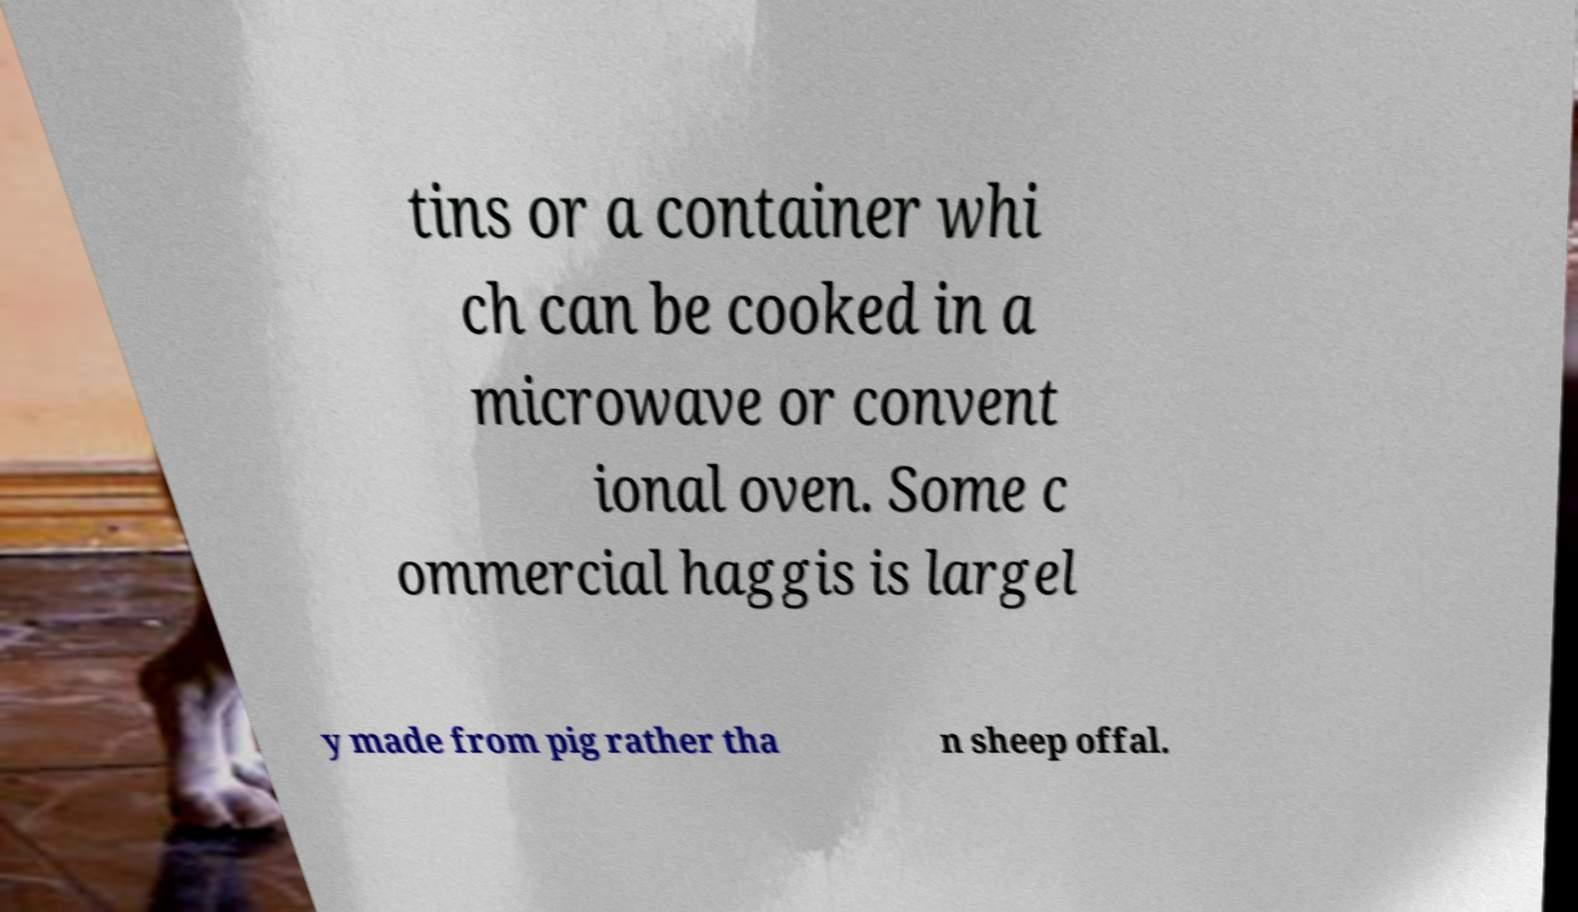Please identify and transcribe the text found in this image. tins or a container whi ch can be cooked in a microwave or convent ional oven. Some c ommercial haggis is largel y made from pig rather tha n sheep offal. 